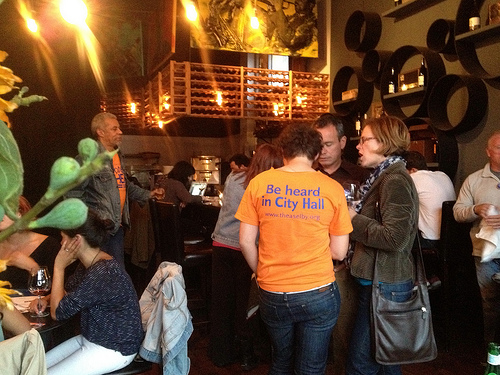<image>
Is there a person under the wine? No. The person is not positioned under the wine. The vertical relationship between these objects is different. 